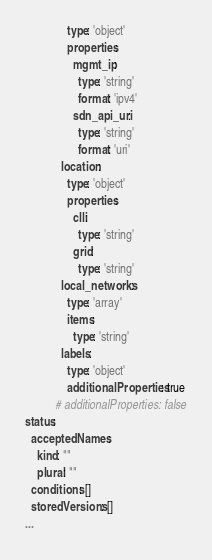<code> <loc_0><loc_0><loc_500><loc_500><_YAML_>              type: 'object'
              properties:
                mgmt_ip:
                  type: 'string'
                  format: 'ipv4'
                sdn_api_uri:
                  type: 'string'
                  format: 'uri'
            location:
              type: 'object'
              properties:
                clli:
                  type: 'string'
                grid:
                  type: 'string'
            local_networks:
              type: 'array'
              items:
                type: 'string'
            labels:
              type: 'object'
              additionalProperties: true
          # additionalProperties: false
status:
  acceptedNames:
    kind: ""
    plural: ""
  conditions: []
  storedVersions: []
...
</code> 